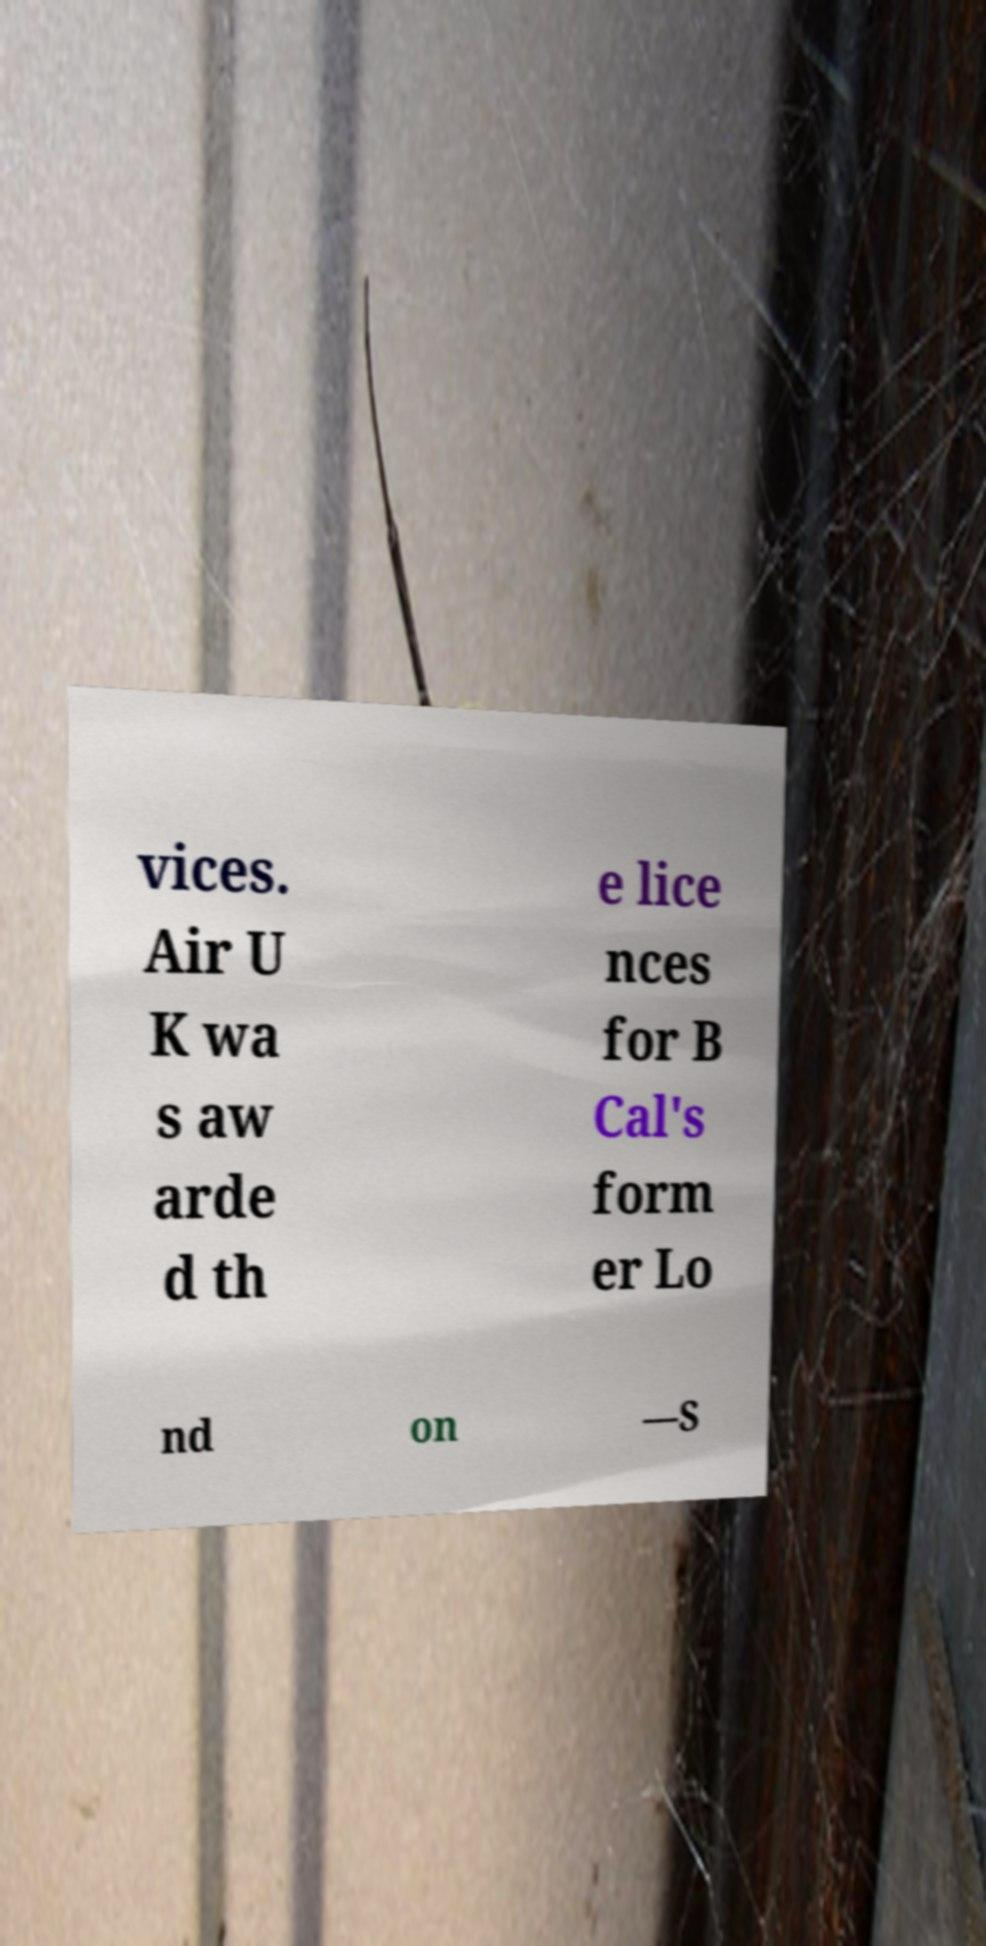There's text embedded in this image that I need extracted. Can you transcribe it verbatim? vices. Air U K wa s aw arde d th e lice nces for B Cal's form er Lo nd on —S 